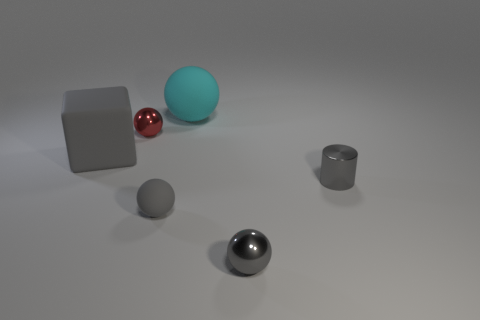Subtract all gray rubber spheres. How many spheres are left? 3 Add 1 big green matte cubes. How many objects exist? 7 Subtract all gray spheres. How many spheres are left? 2 Subtract all red cylinders. How many red spheres are left? 1 Subtract all big gray rubber things. Subtract all tiny matte spheres. How many objects are left? 4 Add 1 tiny balls. How many tiny balls are left? 4 Add 2 tiny purple shiny objects. How many tiny purple shiny objects exist? 2 Subtract 0 green blocks. How many objects are left? 6 Subtract all cubes. How many objects are left? 5 Subtract 1 balls. How many balls are left? 3 